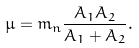Convert formula to latex. <formula><loc_0><loc_0><loc_500><loc_500>\mu = m _ { n } \frac { A _ { 1 } A _ { 2 } } { A _ { 1 } + A _ { 2 } } .</formula> 